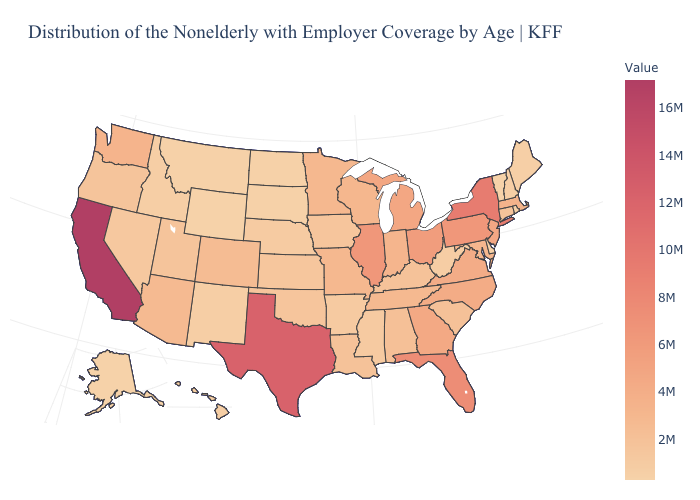Which states hav the highest value in the MidWest?
Short answer required. Illinois. Does Maryland have a higher value than Nevada?
Be succinct. Yes. Which states have the lowest value in the South?
Concise answer only. Delaware. Does the map have missing data?
Answer briefly. No. Does Arizona have the highest value in the West?
Keep it brief. No. Among the states that border New York , does Vermont have the lowest value?
Answer briefly. Yes. 